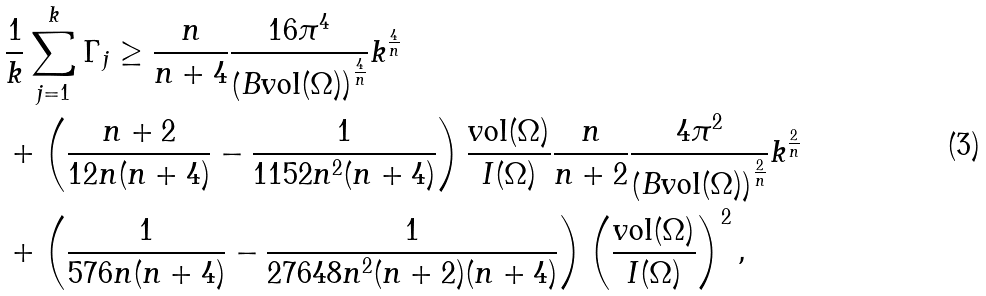<formula> <loc_0><loc_0><loc_500><loc_500>& \frac { 1 } { k } \sum _ { j = 1 } ^ { k } \Gamma _ { j } \geq \frac { n } { n + 4 } \frac { 1 6 \pi ^ { 4 } } { \left ( B \text {vol} ( \Omega ) \right ) ^ { \frac { 4 } { n } } } k ^ { \frac { 4 } { n } } \\ & + \left ( \frac { n + 2 } { 1 2 n ( n + 4 ) } - \frac { 1 } { 1 1 5 2 n ^ { 2 } ( n + 4 ) } \right ) \frac { \text {vol} ( \Omega ) } { I ( \Omega ) } \frac { n } { n + 2 } \frac { 4 \pi ^ { 2 } } { \left ( B \text {vol} ( \Omega ) \right ) ^ { \frac { 2 } { n } } } k ^ { \frac { 2 } { n } } \\ & + \left ( \frac { 1 } { 5 7 6 n ( n + 4 ) } - \frac { 1 } { 2 7 6 4 8 n ^ { 2 } ( n + 2 ) ( n + 4 ) } \right ) \left ( \frac { \text {vol} ( \Omega ) } { I ( \Omega ) } \right ) ^ { 2 } ,</formula> 